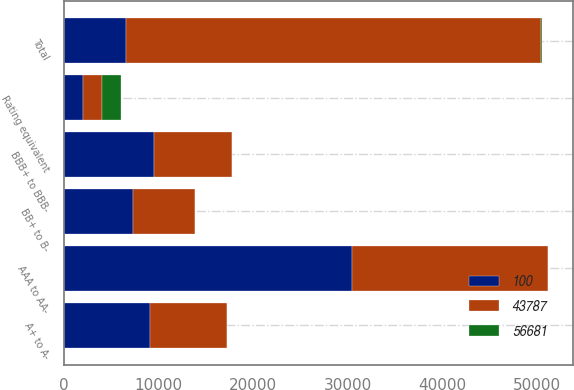<chart> <loc_0><loc_0><loc_500><loc_500><stacked_bar_chart><ecel><fcel>Rating equivalent<fcel>AAA to AA-<fcel>A+ to A-<fcel>BBB+ to BBB-<fcel>BB+ to B-<fcel>Total<nl><fcel>43787<fcel>2005<fcel>20735<fcel>8074<fcel>8243<fcel>6580<fcel>43787<nl><fcel>56681<fcel>2005<fcel>48<fcel>18<fcel>19<fcel>15<fcel>100<nl><fcel>100<fcel>2004<fcel>30384<fcel>9109<fcel>9522<fcel>7271<fcel>6580<nl></chart> 